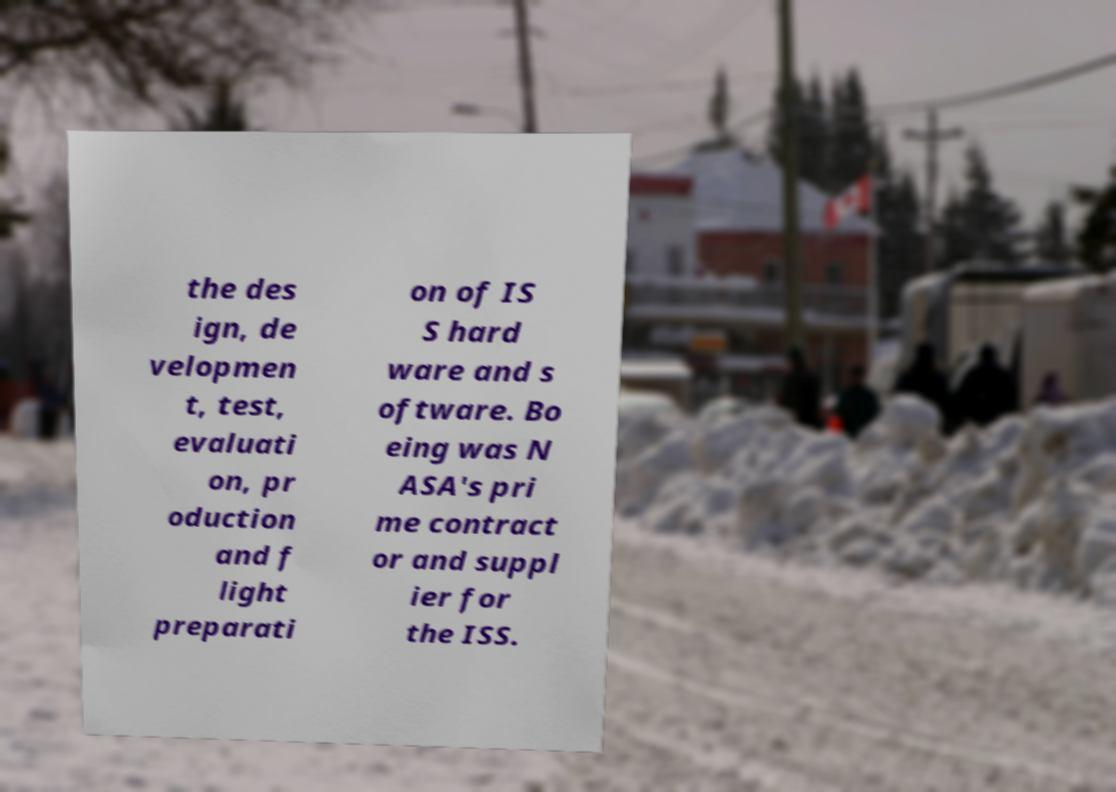Can you accurately transcribe the text from the provided image for me? the des ign, de velopmen t, test, evaluati on, pr oduction and f light preparati on of IS S hard ware and s oftware. Bo eing was N ASA's pri me contract or and suppl ier for the ISS. 